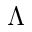<formula> <loc_0><loc_0><loc_500><loc_500>{ \Lambda }</formula> 